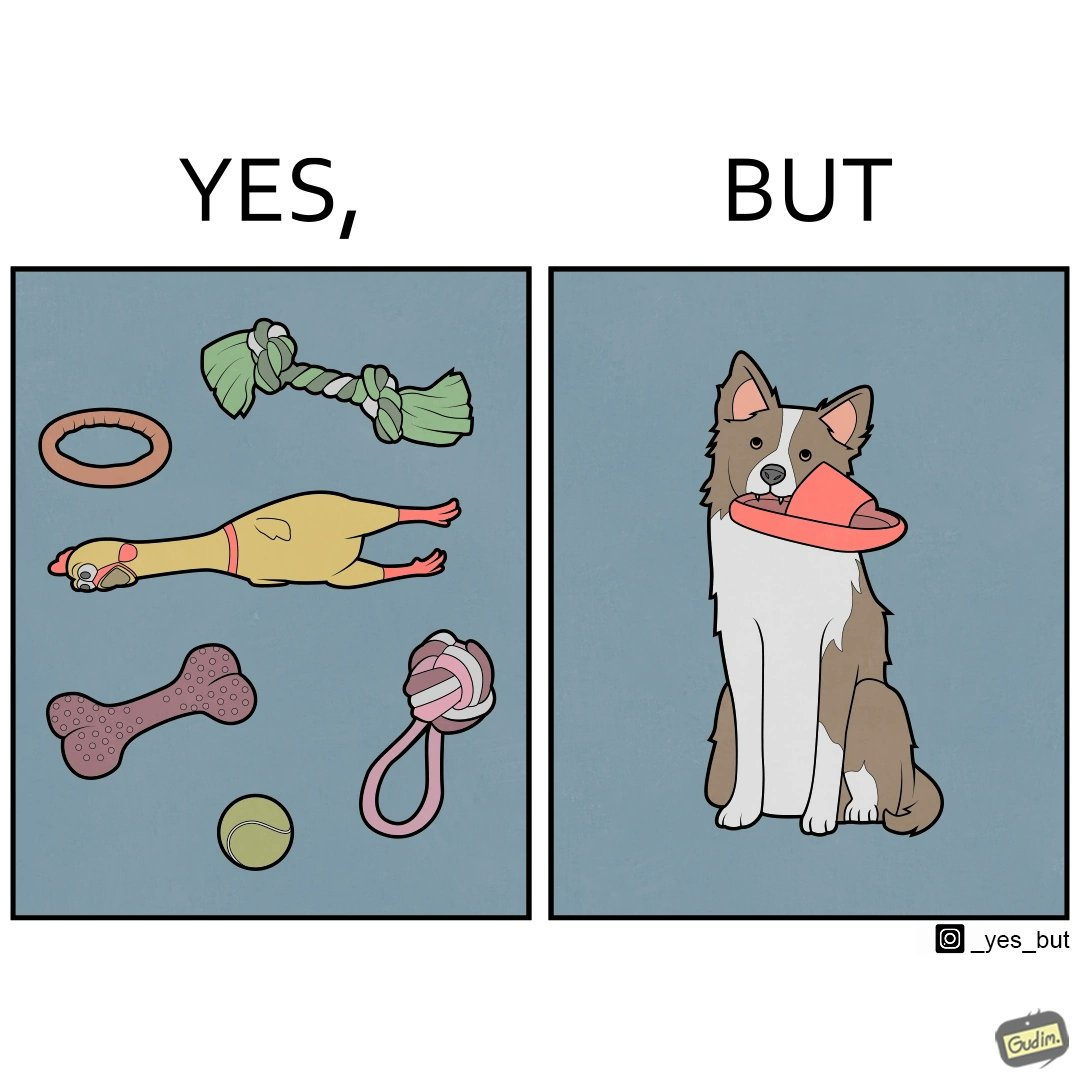Explain the humor or irony in this image. The image is ironical, as even though the dog owner has bought toys for the dog, the dog is playing with a slipper in its mouth. 